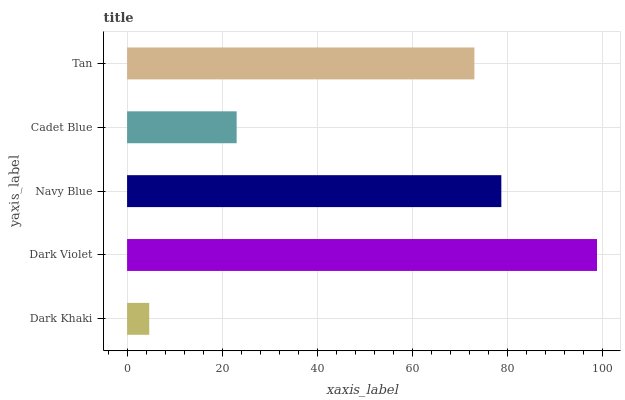Is Dark Khaki the minimum?
Answer yes or no. Yes. Is Dark Violet the maximum?
Answer yes or no. Yes. Is Navy Blue the minimum?
Answer yes or no. No. Is Navy Blue the maximum?
Answer yes or no. No. Is Dark Violet greater than Navy Blue?
Answer yes or no. Yes. Is Navy Blue less than Dark Violet?
Answer yes or no. Yes. Is Navy Blue greater than Dark Violet?
Answer yes or no. No. Is Dark Violet less than Navy Blue?
Answer yes or no. No. Is Tan the high median?
Answer yes or no. Yes. Is Tan the low median?
Answer yes or no. Yes. Is Navy Blue the high median?
Answer yes or no. No. Is Cadet Blue the low median?
Answer yes or no. No. 